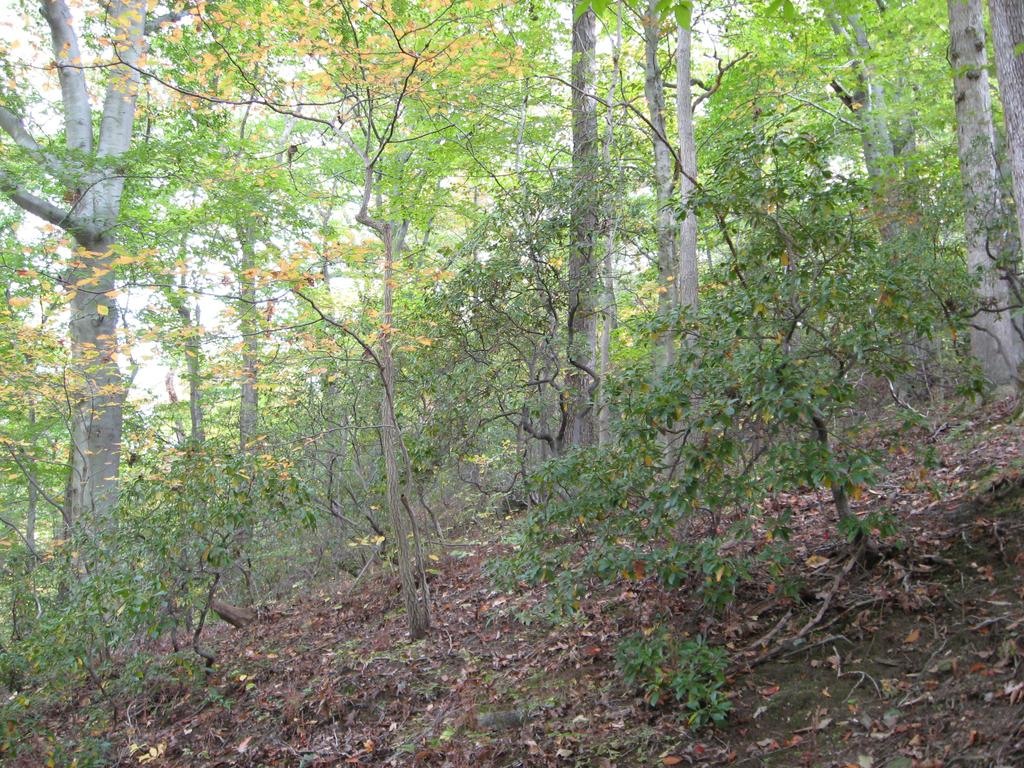What is present on the floor in the image? There is soil and leaves on the floor in the image. What can be seen in the backdrop of the image? There are plants and trees in the backdrop of the image. What is the condition of the sky in the image? The sky is clear in the image. What type of competition is taking place in the image? There is no competition present in the image. Can you hear any music in the image? There is no audio or music present in the image, as it is a still photograph. 